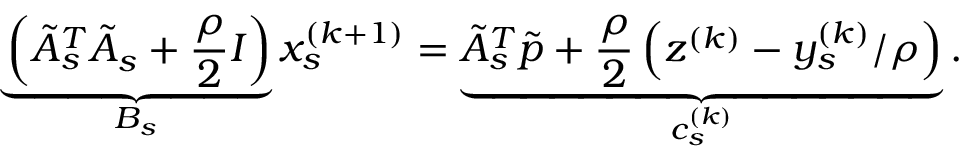<formula> <loc_0><loc_0><loc_500><loc_500>\underbrace { \left ( \tilde { A } _ { s } ^ { T } \tilde { A } _ { s } + \frac { \rho } { 2 } I \right ) } _ { B _ { s } } x _ { s } ^ { ( k + 1 ) } = \underbrace { \tilde { A } _ { s } ^ { T } \tilde { p } + \frac { \rho } { 2 } \left ( z ^ { ( k ) } - y _ { s } ^ { ( k ) } / \rho \right ) } _ { c _ { s } ^ { ( k ) } } .</formula> 